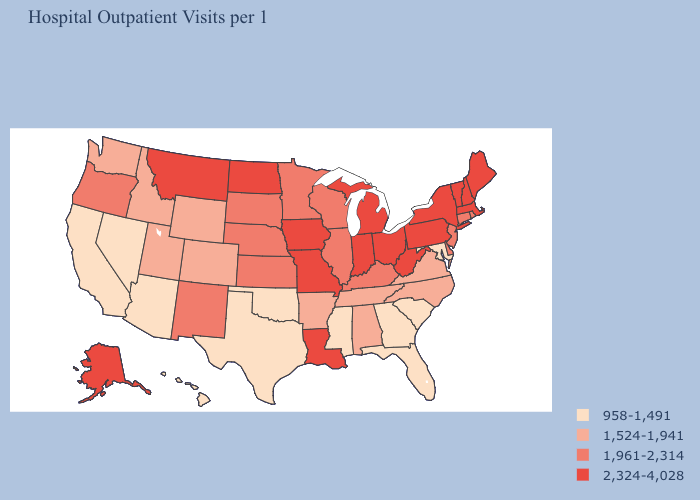Which states have the lowest value in the Northeast?
Write a very short answer. Connecticut, New Jersey, Rhode Island. Does North Carolina have the same value as Wisconsin?
Be succinct. No. Name the states that have a value in the range 1,961-2,314?
Be succinct. Connecticut, Delaware, Illinois, Kansas, Kentucky, Minnesota, Nebraska, New Jersey, New Mexico, Oregon, Rhode Island, South Dakota, Wisconsin. Does Idaho have the lowest value in the West?
Keep it brief. No. What is the value of Massachusetts?
Answer briefly. 2,324-4,028. What is the highest value in the USA?
Short answer required. 2,324-4,028. Among the states that border Kentucky , does Ohio have the highest value?
Quick response, please. Yes. Among the states that border New Mexico , does Texas have the highest value?
Write a very short answer. No. What is the value of Florida?
Keep it brief. 958-1,491. What is the value of Oregon?
Concise answer only. 1,961-2,314. Name the states that have a value in the range 1,524-1,941?
Keep it brief. Alabama, Arkansas, Colorado, Idaho, North Carolina, Tennessee, Utah, Virginia, Washington, Wyoming. Name the states that have a value in the range 958-1,491?
Keep it brief. Arizona, California, Florida, Georgia, Hawaii, Maryland, Mississippi, Nevada, Oklahoma, South Carolina, Texas. Name the states that have a value in the range 1,961-2,314?
Short answer required. Connecticut, Delaware, Illinois, Kansas, Kentucky, Minnesota, Nebraska, New Jersey, New Mexico, Oregon, Rhode Island, South Dakota, Wisconsin. Name the states that have a value in the range 1,524-1,941?
Give a very brief answer. Alabama, Arkansas, Colorado, Idaho, North Carolina, Tennessee, Utah, Virginia, Washington, Wyoming. What is the lowest value in the USA?
Write a very short answer. 958-1,491. 